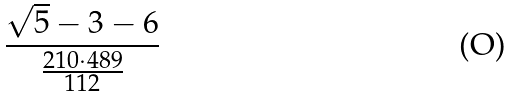Convert formula to latex. <formula><loc_0><loc_0><loc_500><loc_500>\frac { \sqrt { 5 } - 3 - 6 } { \frac { 2 1 0 \cdot 4 8 9 } { 1 1 2 } }</formula> 